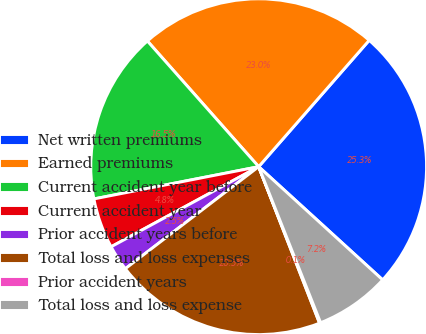Convert chart to OTSL. <chart><loc_0><loc_0><loc_500><loc_500><pie_chart><fcel>Net written premiums<fcel>Earned premiums<fcel>Current accident year before<fcel>Current accident year<fcel>Prior accident years before<fcel>Total loss and loss expenses<fcel>Prior accident years<fcel>Total loss and loss expense<nl><fcel>25.34%<fcel>22.97%<fcel>16.54%<fcel>4.84%<fcel>2.48%<fcel>20.51%<fcel>0.11%<fcel>7.21%<nl></chart> 